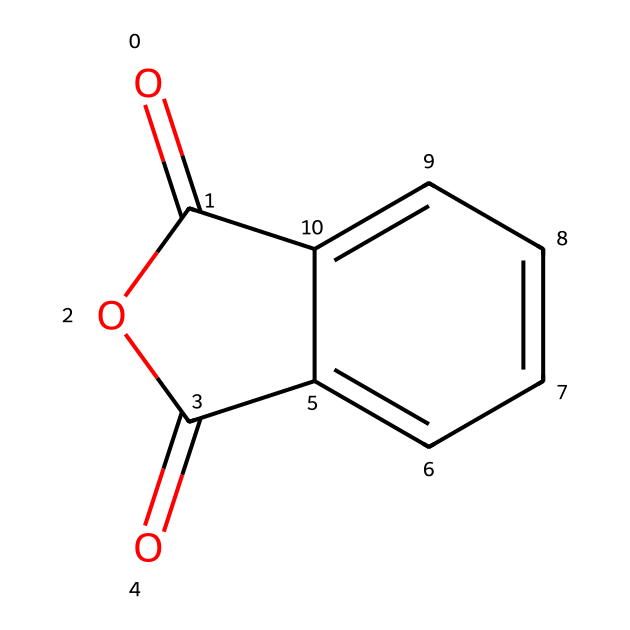What is the name of this chemical? The provided SMILES representation corresponds to a common chemical recognized in industries and scientific literature. Matching the structure to known databases, this is identified as phthalic anhydride.
Answer: phthalic anhydride How many carbon atoms are present in phthalic anhydride? By analyzing the structure through the SMILES notation, I can count the number of carbon atoms in the ring and the substituent groups. In the case of phthalic anhydride, there are 8 carbon atoms in total.
Answer: 8 How many oxygen atoms are in phthalic anhydride? From the SMILES string, I can identify the elements indicated. The presence of double-bonded oxygens and the cyclic structure indicates that there are 3 oxygen atoms within the phthalic anhydride structure.
Answer: 3 What type of functional groups are present in this chemical? Examining the chemical structure outlined by the SMILES, it indicates the presence of an anhydride functional group as denoted by the two carbonyl groups. This classifies it specifically as an acid anhydride.
Answer: acid anhydride Is phthalic anhydride considered a cyclic compound? The structure depicted by the SMILES notation shows a cyclic arrangement of atoms due to the presence of a ring structure, confirming that it is indeed a cyclic compound.
Answer: yes What is the primary application of phthalic anhydride in the aerospace industry? Phthalic anhydride is utilized mainly for the production of resins and plastics, which are essential in aerospace manufacturing, especially for composites. This is due to its ability to form durable polymers.
Answer: resins 